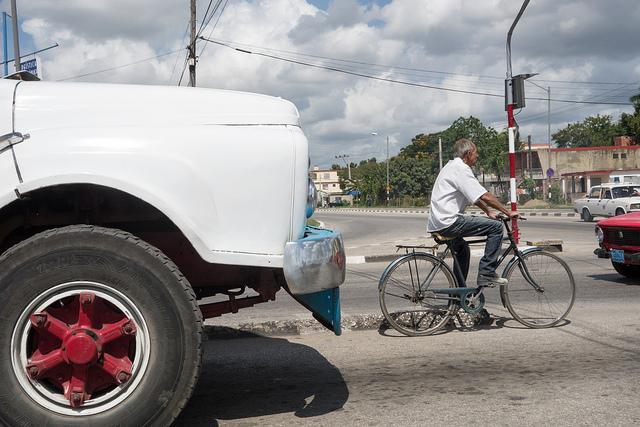What color rims does the truck have?
Give a very brief answer. Red. Is a man driving?
Short answer required. No. What  is the man riding?
Concise answer only. Bike. Is the man on the bike on a sidewalk?
Quick response, please. No. 